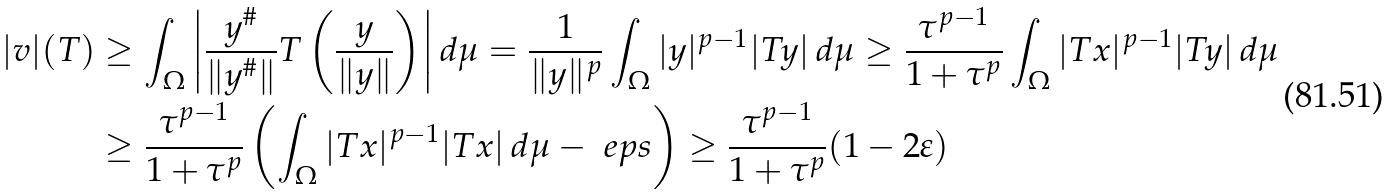<formula> <loc_0><loc_0><loc_500><loc_500>| v | ( T ) & \geq \int _ { \Omega } \left | \frac { y ^ { \# } } { \| y ^ { \# } \| } T \left ( \frac { y } { \| y \| } \right ) \right | d \mu = \frac { 1 } { \| y \| ^ { p } } \int _ { \Omega } | y | ^ { p - 1 } | T y | \, d \mu \geq \frac { \tau ^ { p - 1 } } { 1 + \tau ^ { p } } \int _ { \Omega } | T x | ^ { p - 1 } | T y | \, d \mu \\ & \geq \frac { \tau ^ { p - 1 } } { 1 + \tau ^ { p } } \left ( \int _ { \Omega } | T x | ^ { p - 1 } | T x | \, d \mu - \ e p s \right ) \geq \frac { \tau ^ { p - 1 } } { 1 + \tau ^ { p } } ( 1 - 2 \varepsilon )</formula> 